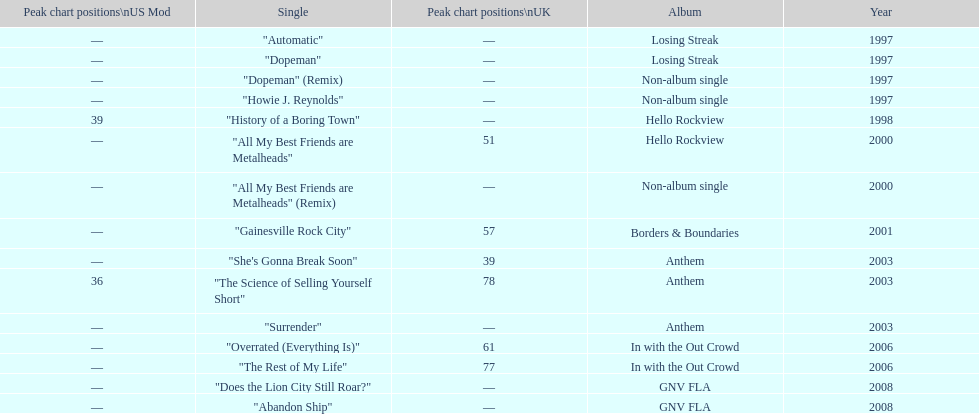What was the average chart position of their singles in the uk? 60.5. 